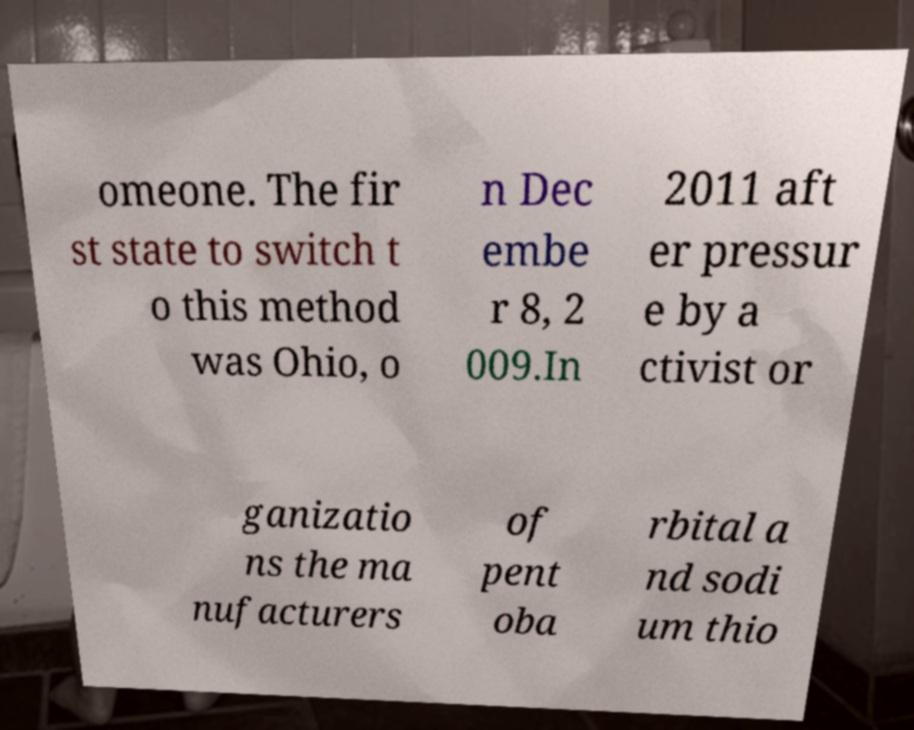Please identify and transcribe the text found in this image. omeone. The fir st state to switch t o this method was Ohio, o n Dec embe r 8, 2 009.In 2011 aft er pressur e by a ctivist or ganizatio ns the ma nufacturers of pent oba rbital a nd sodi um thio 